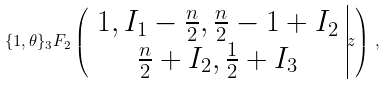Convert formula to latex. <formula><loc_0><loc_0><loc_500><loc_500>\{ 1 , \theta \} _ { 3 } F _ { 2 } \left ( \begin{array} { c | } 1 , I _ { 1 } - \frac { n } { 2 } , \frac { n } { 2 } - 1 + I _ { 2 } \\ \frac { n } { 2 } + I _ { 2 } , \frac { 1 } { 2 } + I _ { 3 } \end{array} z \right ) \, ,</formula> 